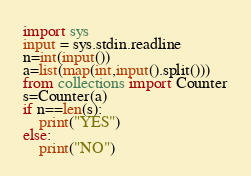<code> <loc_0><loc_0><loc_500><loc_500><_Python_>import sys
input = sys.stdin.readline
n=int(input())
a=list(map(int,input().split()))
from collections import Counter
s=Counter(a)
if n==len(s):
    print("YES")
else:
    print("NO")
</code> 